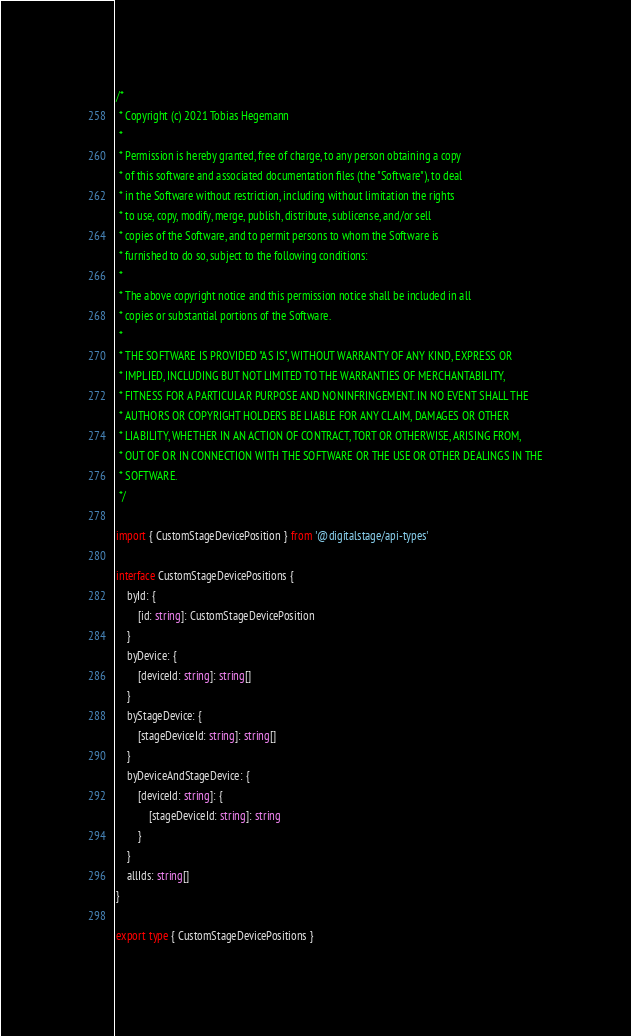Convert code to text. <code><loc_0><loc_0><loc_500><loc_500><_TypeScript_>/*
 * Copyright (c) 2021 Tobias Hegemann
 *
 * Permission is hereby granted, free of charge, to any person obtaining a copy
 * of this software and associated documentation files (the "Software"), to deal
 * in the Software without restriction, including without limitation the rights
 * to use, copy, modify, merge, publish, distribute, sublicense, and/or sell
 * copies of the Software, and to permit persons to whom the Software is
 * furnished to do so, subject to the following conditions:
 *
 * The above copyright notice and this permission notice shall be included in all
 * copies or substantial portions of the Software.
 *
 * THE SOFTWARE IS PROVIDED "AS IS", WITHOUT WARRANTY OF ANY KIND, EXPRESS OR
 * IMPLIED, INCLUDING BUT NOT LIMITED TO THE WARRANTIES OF MERCHANTABILITY,
 * FITNESS FOR A PARTICULAR PURPOSE AND NONINFRINGEMENT. IN NO EVENT SHALL THE
 * AUTHORS OR COPYRIGHT HOLDERS BE LIABLE FOR ANY CLAIM, DAMAGES OR OTHER
 * LIABILITY, WHETHER IN AN ACTION OF CONTRACT, TORT OR OTHERWISE, ARISING FROM,
 * OUT OF OR IN CONNECTION WITH THE SOFTWARE OR THE USE OR OTHER DEALINGS IN THE
 * SOFTWARE.
 */

import { CustomStageDevicePosition } from '@digitalstage/api-types'

interface CustomStageDevicePositions {
    byId: {
        [id: string]: CustomStageDevicePosition
    }
    byDevice: {
        [deviceId: string]: string[]
    }
    byStageDevice: {
        [stageDeviceId: string]: string[]
    }
    byDeviceAndStageDevice: {
        [deviceId: string]: {
            [stageDeviceId: string]: string
        }
    }
    allIds: string[]
}

export type { CustomStageDevicePositions }
</code> 